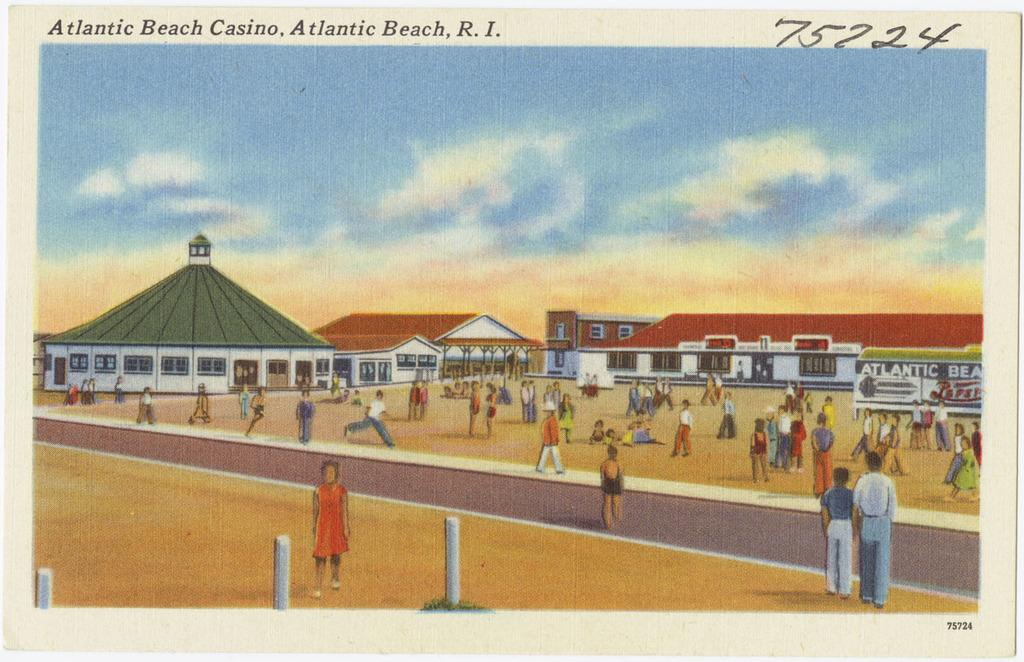What is the main subject of the poster in the image? The poster depicts buildings and many persons. What can be seen in the sky in the poster? There are clouds in the sky in the poster. What is visible at the bottom of the poster? There is ground visible in the poster. How many things can be seen floating in the water in the image? There is no water present in the image, and therefore no floating objects can be observed. 